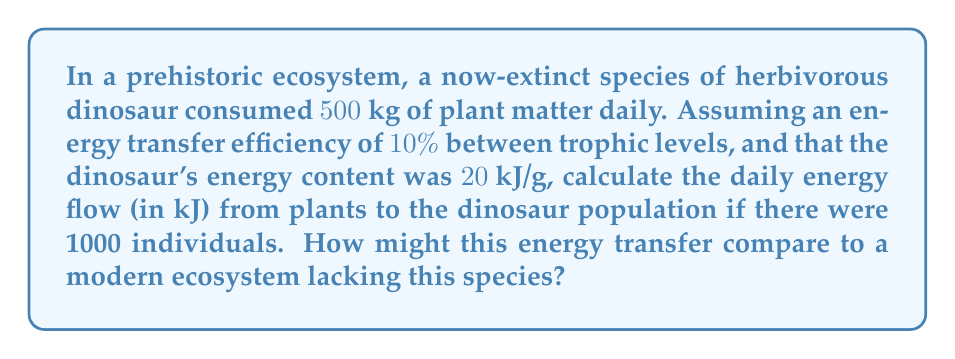Provide a solution to this math problem. To solve this problem, we'll follow these steps:

1) First, we need to calculate the total plant matter consumed by the dinosaur population daily:
   $500 \text{ kg/dinosaur} \times 1000 \text{ dinosaurs} = 500,000 \text{ kg}$ of plant matter

2) Convert this to grams:
   $500,000 \text{ kg} \times 1000 \text{ g/kg} = 500,000,000 \text{ g}$ of plant matter

3) Now, we need to calculate the energy content of this plant matter. However, we don't have this information directly. Instead, we can use the energy transfer efficiency to work backwards from the dinosaur's energy content.

4) The energy transfer efficiency is $10\%$ or $0.1$. This means that only $10\%$ of the energy in the plants is transferred to the dinosaurs. We can express this as:

   $E_{dinosaur} = 0.1 \times E_{plant}$

   Where $E$ represents energy.

5) We know the dinosaur's energy content is $20 \text{ kJ/g}$. So:

   $20 \text{ kJ/g} = 0.1 \times E_{plant}$

6) Solving for $E_{plant}$:

   $E_{plant} = \frac{20 \text{ kJ/g}}{0.1} = 200 \text{ kJ/g}$

7) Now we can calculate the total energy flow:

   $500,000,000 \text{ g} \times 200 \text{ kJ/g} = 100,000,000,000 \text{ kJ}$

8) This enormous energy flow of $100$ billion kJ daily would likely be significantly larger than what we observe in modern ecosystems lacking such large herbivores. Modern ecosystems might have more distributed energy flows across a greater diversity of smaller species.
Answer: The daily energy flow from plants to the dinosaur population is $100,000,000,000 \text{ kJ}$ or $100$ billion kJ. 